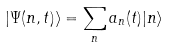<formula> <loc_0><loc_0><loc_500><loc_500>| \Psi ( n , t ) \rangle = \sum _ { n } a _ { n } ( t ) | n \rangle</formula> 